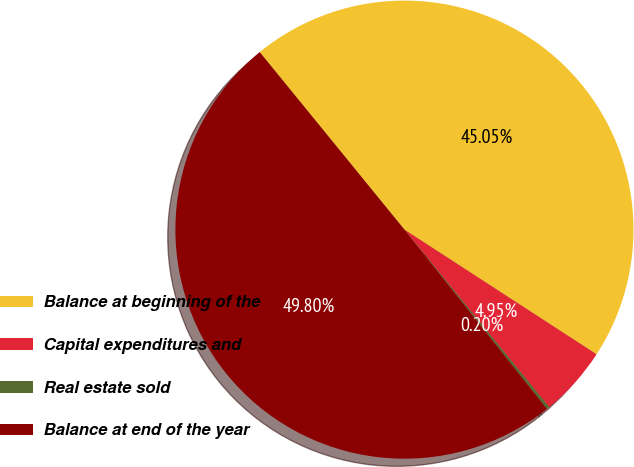Convert chart. <chart><loc_0><loc_0><loc_500><loc_500><pie_chart><fcel>Balance at beginning of the<fcel>Capital expenditures and<fcel>Real estate sold<fcel>Balance at end of the year<nl><fcel>45.05%<fcel>4.95%<fcel>0.2%<fcel>49.8%<nl></chart> 